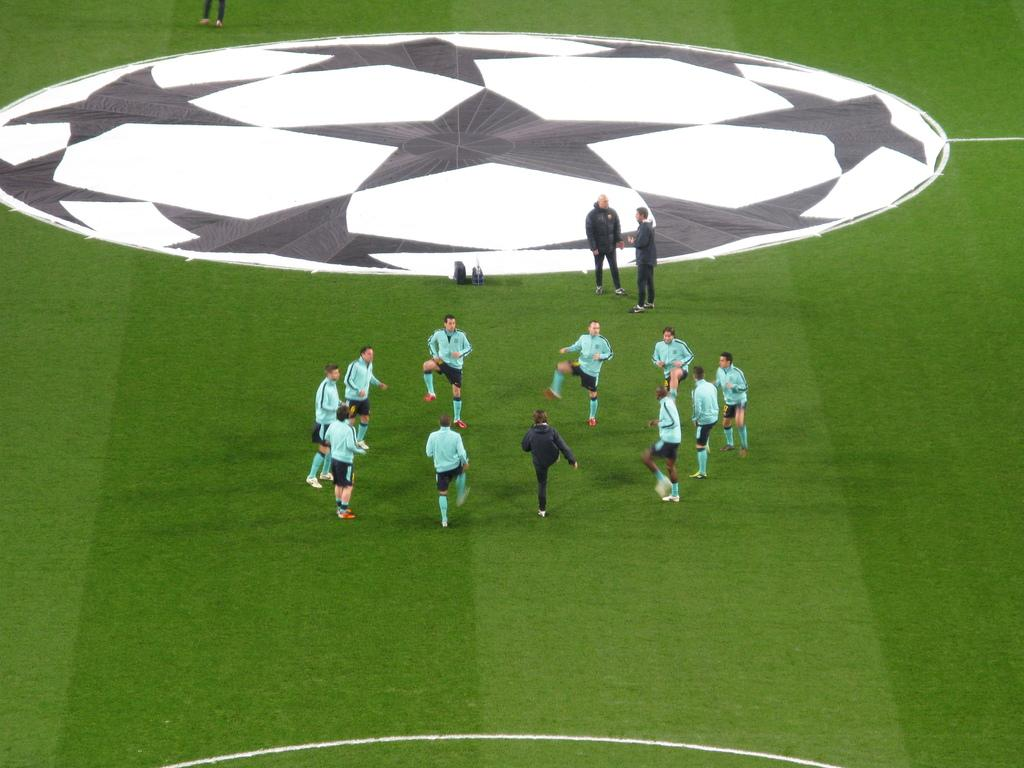What is happening in the image? There are people standing in the image. Can you describe any specific details about the image? There might be a black and white cloth in the image, and it appears to be set on a ground. What part of a person's body is visible at the top of the image? A person's legs are visible at the top of the image. How many worms can be seen crawling on the person's trousers in the image? There are no worms visible in the image, and no trousers are mentioned in the provided facts. --- Facts: 1. There is a person sitting on a chair in the image. 2. The person is holding a book. 3. The book has a red cover. 4. There is a table next to the chair. 5. A lamp is on the table. Absurd Topics: parrot, ocean, bicycle Conversation: What is the person in the image doing? The person is sitting on a chair in the image. What is the person holding in the image? The person is holding a book in the image. Can you describe the book's appearance? The book has a red cover. What is located next to the chair in the image? There is a table next to the chair in the image. What object is on the table? A lamp is on the table in the image. Reasoning: Let's think step by step in order to produce the conversation. We start by identifying the main subject in the image, which is the person sitting on a chair. Then, we describe what the person is holding, which is a book with a red cover. Next, we mention the presence of a table next to the chair and the lamp on the table. Each question is designed to elicit a specific detail about the image that is known from the provided facts. Absurd Question/Answer: Can you see any parrots flying over the ocean in the image? There are no parrots or ocean visible in the image; it features a person sitting on a chair holding a book with a red cover. 